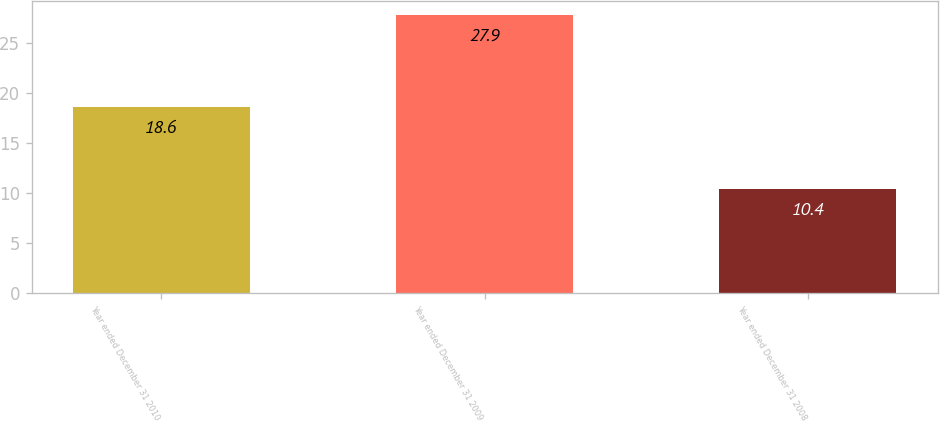<chart> <loc_0><loc_0><loc_500><loc_500><bar_chart><fcel>Year ended December 31 2010<fcel>Year ended December 31 2009<fcel>Year ended December 31 2008<nl><fcel>18.6<fcel>27.9<fcel>10.4<nl></chart> 